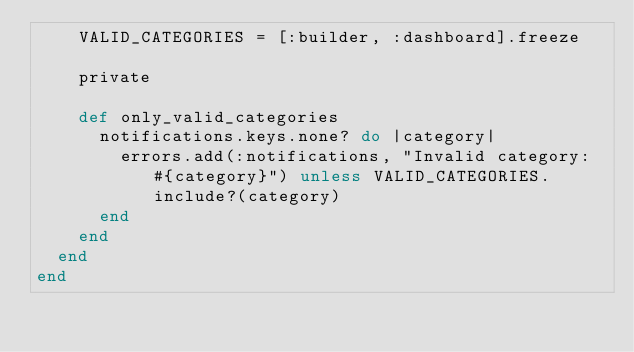<code> <loc_0><loc_0><loc_500><loc_500><_Ruby_>    VALID_CATEGORIES = [:builder, :dashboard].freeze

    private

    def only_valid_categories
      notifications.keys.none? do |category|
        errors.add(:notifications, "Invalid category: #{category}") unless VALID_CATEGORIES.include?(category)
      end
    end
  end
end
</code> 